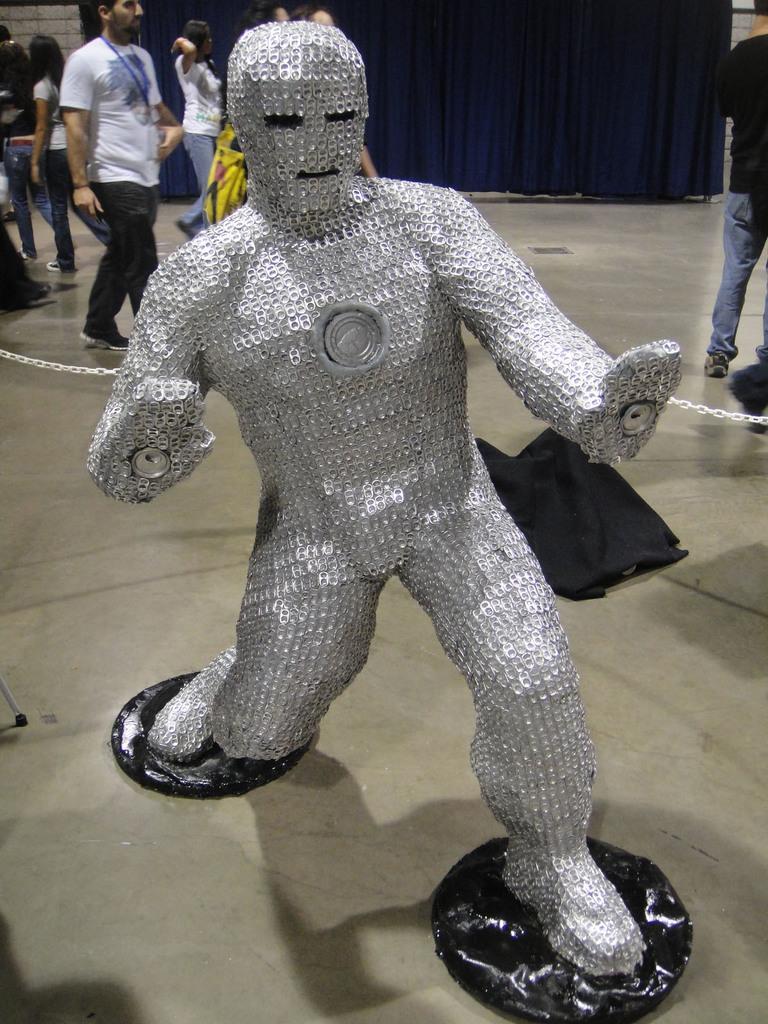Can you describe this image briefly? In this image, at the middle there is a silver color statue, there is a floor, there are some people walking, at the background there is a blue color curtain. 